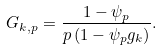Convert formula to latex. <formula><loc_0><loc_0><loc_500><loc_500>G _ { k , p } = \frac { 1 - \psi _ { p } } { p \left ( 1 - \psi _ { p } g _ { k } \right ) } .</formula> 